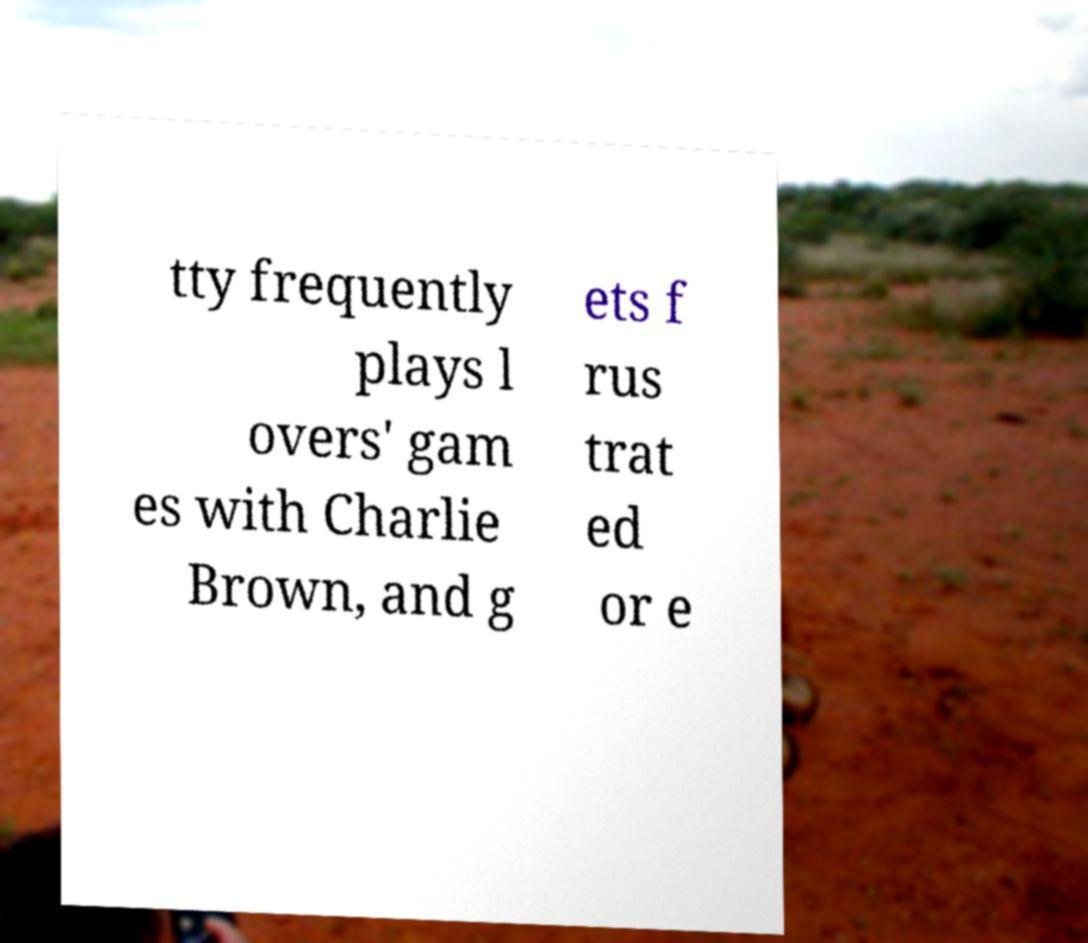Can you read and provide the text displayed in the image?This photo seems to have some interesting text. Can you extract and type it out for me? tty frequently plays l overs' gam es with Charlie Brown, and g ets f rus trat ed or e 